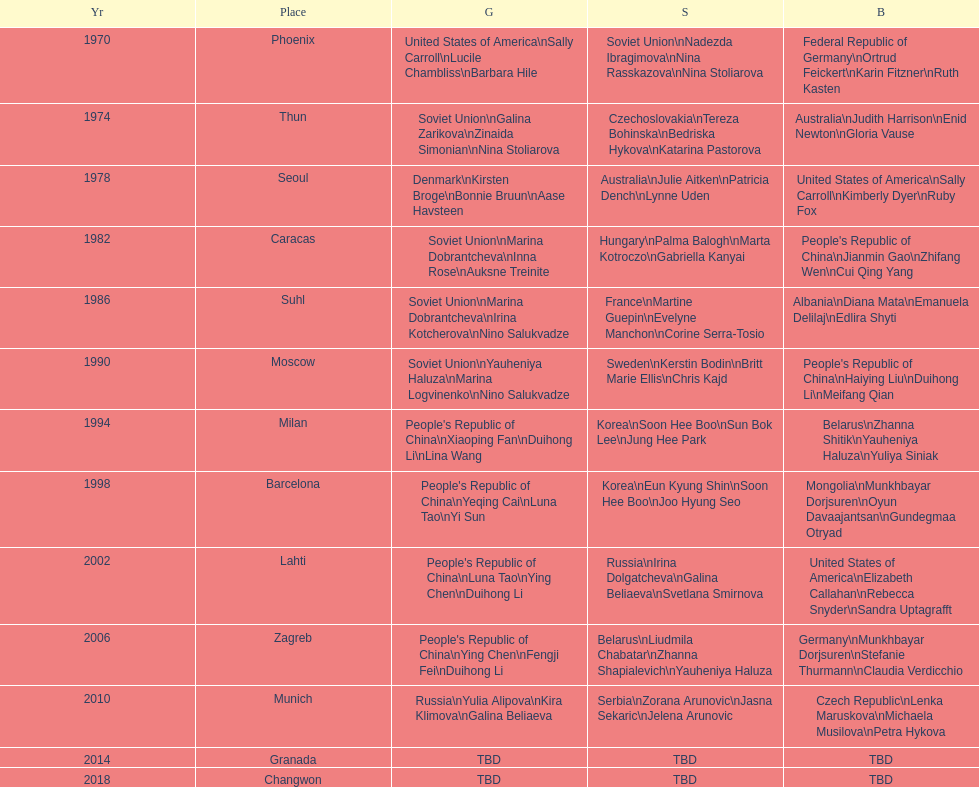What is the first place listed in this chart? Phoenix. 